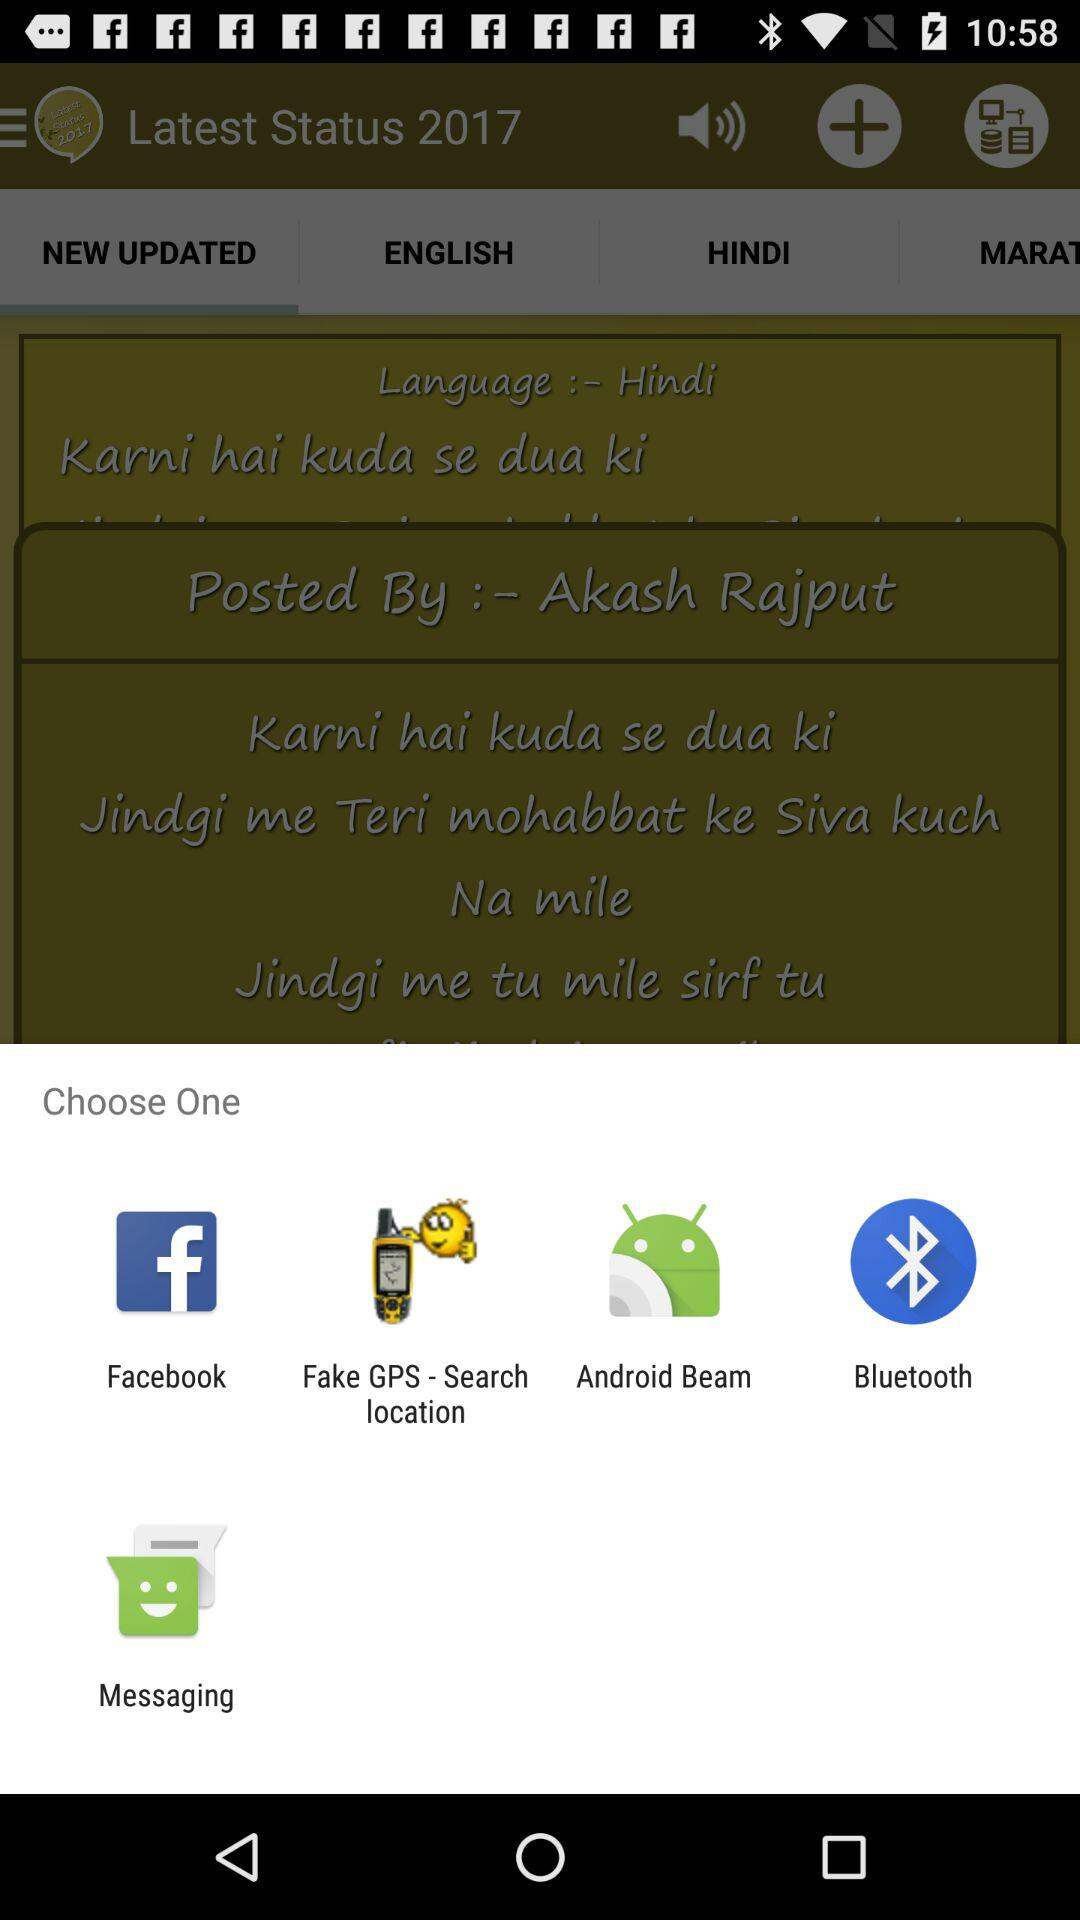What application can i use to choose one? You can choose "Facebook", "Fake GPS - Search location", "Android Beam"," Bluetooth" and "Messaging". 